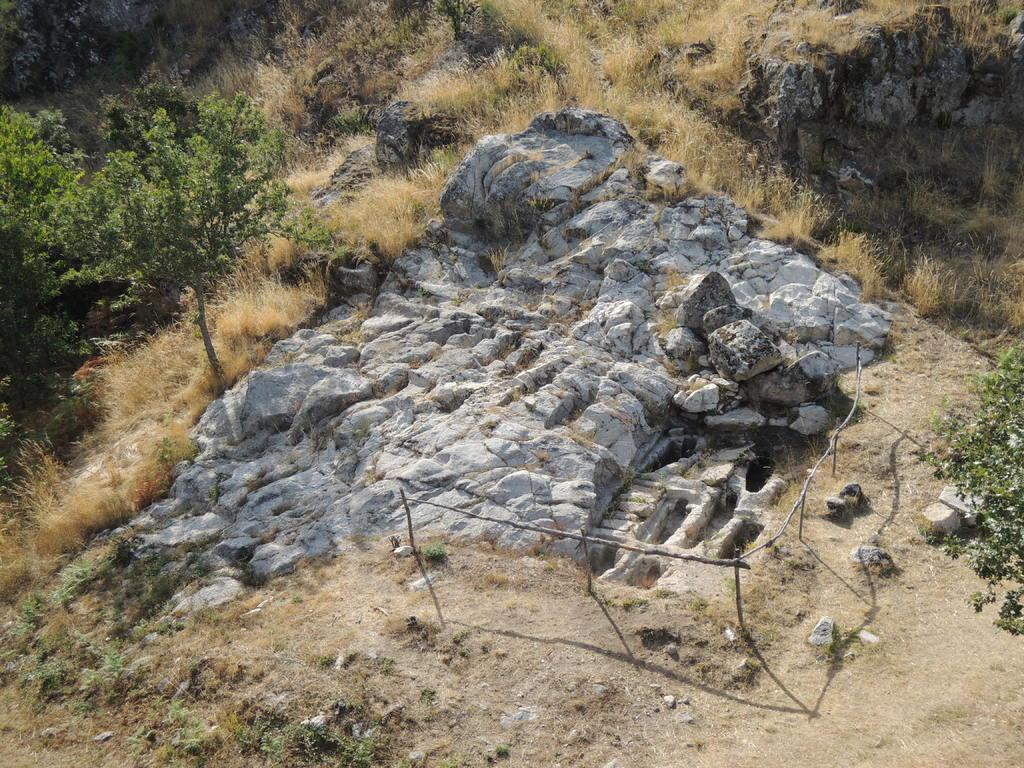What is located in the foreground of the image? There are stones and bamboos in the foreground of the image. What type of vegetation can be seen in the foreground? Bamboos are visible in the foreground of the image. What can be seen in the background of the image? There are trees and dry grass in the background of the image. How many flies can be seen on the string in the image? There is no string or fly present in the image. What type of balance is demonstrated by the bamboos in the image? The bamboos in the image are not demonstrating any balance; they are simply standing upright. 